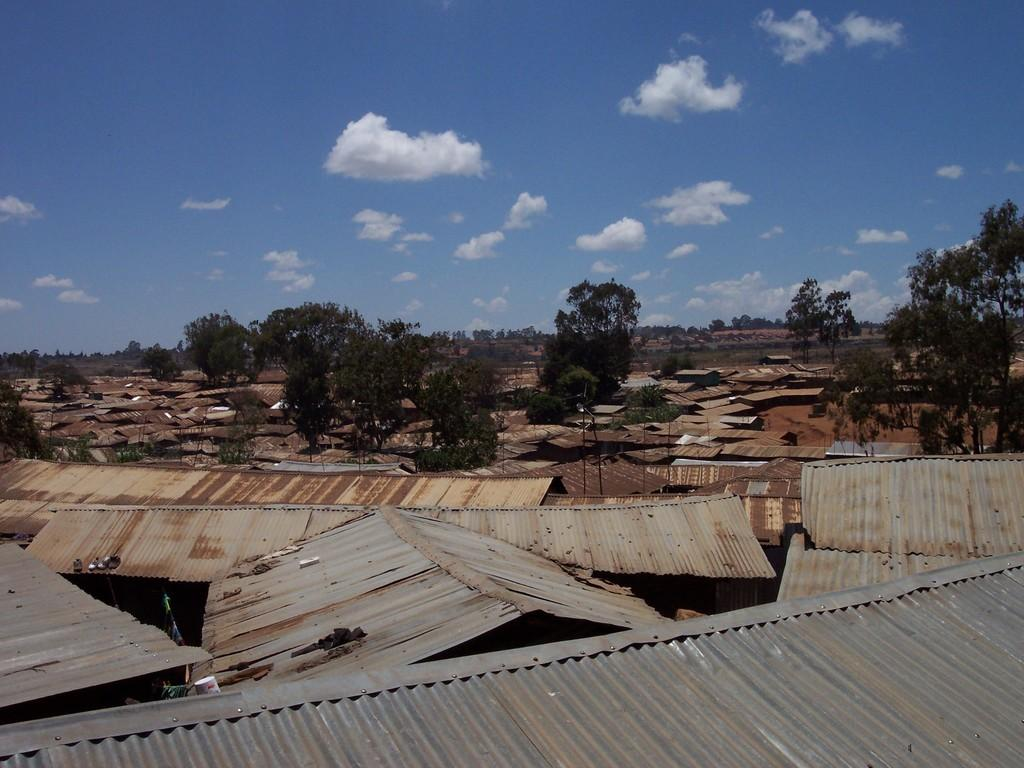What material is used for the roofing of the houses in the image? Metal sheets are used as roofing on houses in the image. What type of vegetation can be seen in the image? There are trees in the image. Can you describe the background of the image? There are trees visible in the background of the image, and there are clouds in the sky. What scent can be detected from the trees in the image? There is no information about the scent of the trees in the image, as we are only looking at a visual representation. 